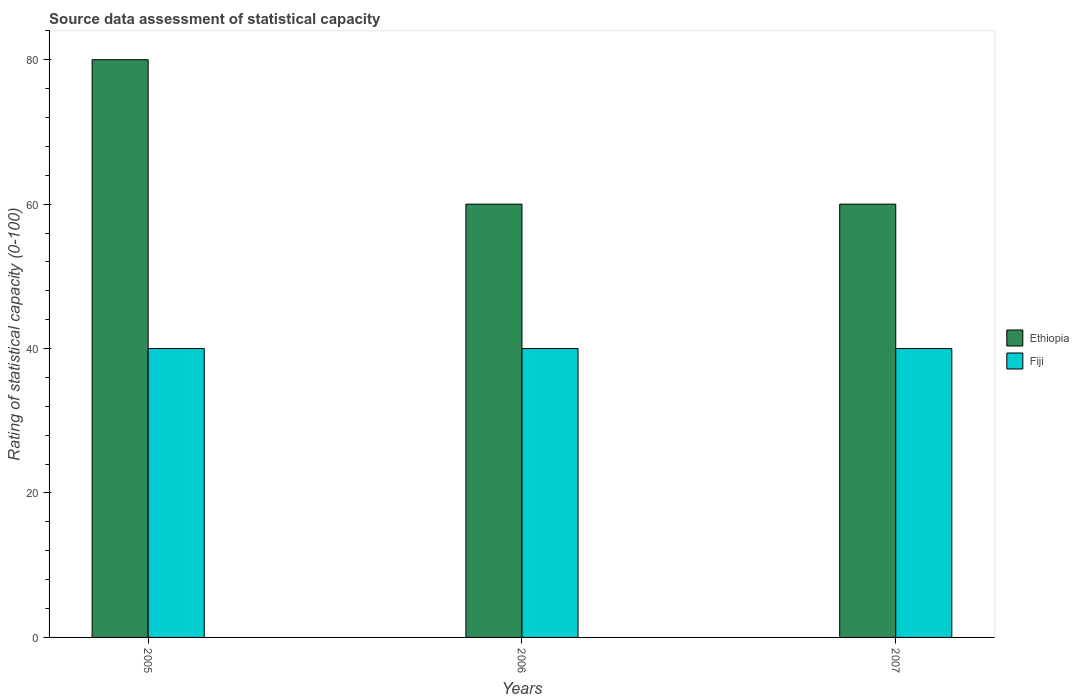How many different coloured bars are there?
Keep it short and to the point. 2. Are the number of bars per tick equal to the number of legend labels?
Provide a succinct answer. Yes. Are the number of bars on each tick of the X-axis equal?
Give a very brief answer. Yes. How many bars are there on the 2nd tick from the right?
Your response must be concise. 2. What is the label of the 2nd group of bars from the left?
Your response must be concise. 2006. Across all years, what is the maximum rating of statistical capacity in Ethiopia?
Provide a short and direct response. 80. In which year was the rating of statistical capacity in Ethiopia maximum?
Ensure brevity in your answer.  2005. What is the total rating of statistical capacity in Ethiopia in the graph?
Offer a terse response. 200. What is the average rating of statistical capacity in Fiji per year?
Make the answer very short. 40. In the year 2006, what is the difference between the rating of statistical capacity in Fiji and rating of statistical capacity in Ethiopia?
Provide a succinct answer. -20. What is the difference between the highest and the second highest rating of statistical capacity in Ethiopia?
Your response must be concise. 20. What is the difference between the highest and the lowest rating of statistical capacity in Ethiopia?
Ensure brevity in your answer.  20. Is the sum of the rating of statistical capacity in Fiji in 2006 and 2007 greater than the maximum rating of statistical capacity in Ethiopia across all years?
Your answer should be very brief. No. What does the 2nd bar from the left in 2005 represents?
Offer a terse response. Fiji. What does the 2nd bar from the right in 2005 represents?
Make the answer very short. Ethiopia. How many years are there in the graph?
Your response must be concise. 3. Does the graph contain any zero values?
Ensure brevity in your answer.  No. What is the title of the graph?
Give a very brief answer. Source data assessment of statistical capacity. What is the label or title of the Y-axis?
Your answer should be compact. Rating of statistical capacity (0-100). What is the Rating of statistical capacity (0-100) of Fiji in 2006?
Your answer should be compact. 40. What is the Rating of statistical capacity (0-100) of Ethiopia in 2007?
Offer a very short reply. 60. Across all years, what is the maximum Rating of statistical capacity (0-100) in Ethiopia?
Your answer should be very brief. 80. Across all years, what is the minimum Rating of statistical capacity (0-100) in Ethiopia?
Keep it short and to the point. 60. What is the total Rating of statistical capacity (0-100) in Ethiopia in the graph?
Offer a terse response. 200. What is the total Rating of statistical capacity (0-100) of Fiji in the graph?
Your answer should be compact. 120. What is the difference between the Rating of statistical capacity (0-100) in Ethiopia in 2006 and that in 2007?
Offer a terse response. 0. What is the difference between the Rating of statistical capacity (0-100) in Fiji in 2006 and that in 2007?
Ensure brevity in your answer.  0. What is the difference between the Rating of statistical capacity (0-100) in Ethiopia in 2005 and the Rating of statistical capacity (0-100) in Fiji in 2006?
Your answer should be compact. 40. What is the difference between the Rating of statistical capacity (0-100) in Ethiopia in 2005 and the Rating of statistical capacity (0-100) in Fiji in 2007?
Provide a short and direct response. 40. What is the average Rating of statistical capacity (0-100) in Ethiopia per year?
Provide a short and direct response. 66.67. What is the average Rating of statistical capacity (0-100) of Fiji per year?
Provide a short and direct response. 40. In the year 2006, what is the difference between the Rating of statistical capacity (0-100) in Ethiopia and Rating of statistical capacity (0-100) in Fiji?
Give a very brief answer. 20. In the year 2007, what is the difference between the Rating of statistical capacity (0-100) in Ethiopia and Rating of statistical capacity (0-100) in Fiji?
Offer a terse response. 20. What is the ratio of the Rating of statistical capacity (0-100) of Ethiopia in 2005 to that in 2006?
Provide a succinct answer. 1.33. What is the ratio of the Rating of statistical capacity (0-100) of Ethiopia in 2005 to that in 2007?
Give a very brief answer. 1.33. 